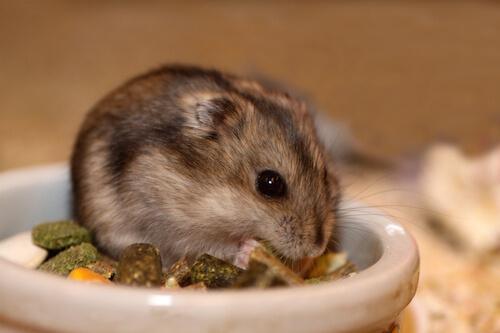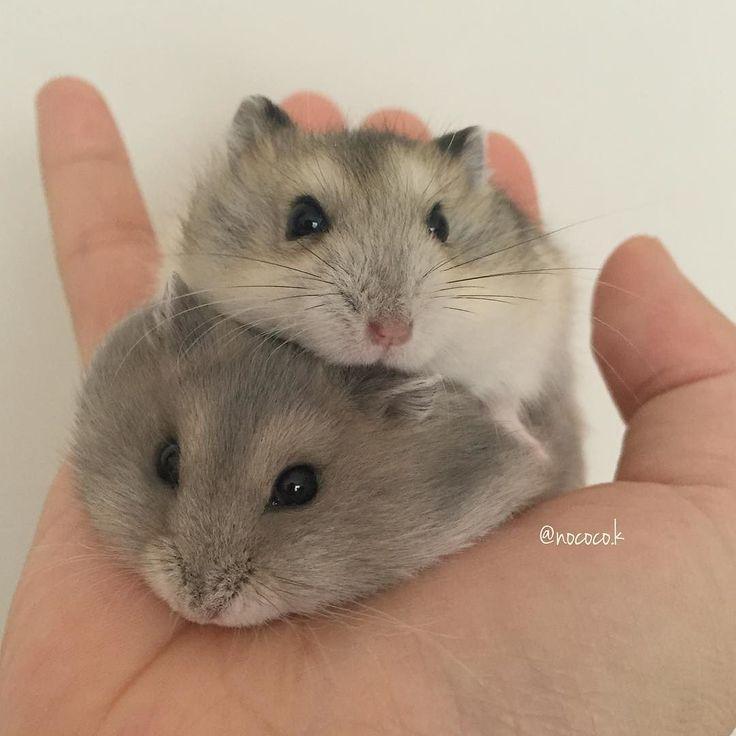The first image is the image on the left, the second image is the image on the right. Examine the images to the left and right. Is the description "One image shows a hand holding more than one small rodent." accurate? Answer yes or no. Yes. The first image is the image on the left, the second image is the image on the right. For the images shown, is this caption "A human hand is holding some hamsters." true? Answer yes or no. Yes. 